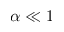<formula> <loc_0><loc_0><loc_500><loc_500>\alpha \ll 1</formula> 